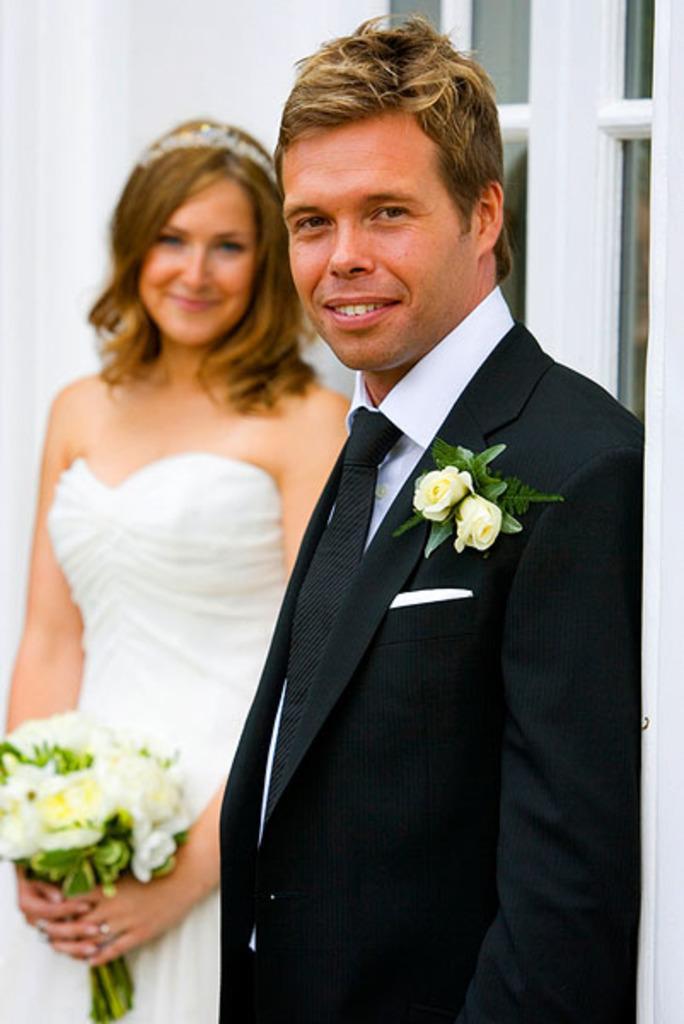How would you summarize this image in a sentence or two? This is the man and woman standing and smiling. This man wore a suit, tie and shirt. These are the flowers attached to the suit. This woman is holding a flower bouquet in her hands. She wore a white frock and a crown. This looks like a door. 